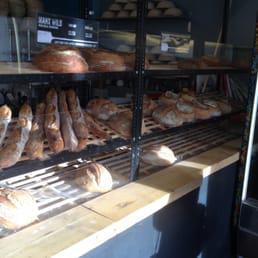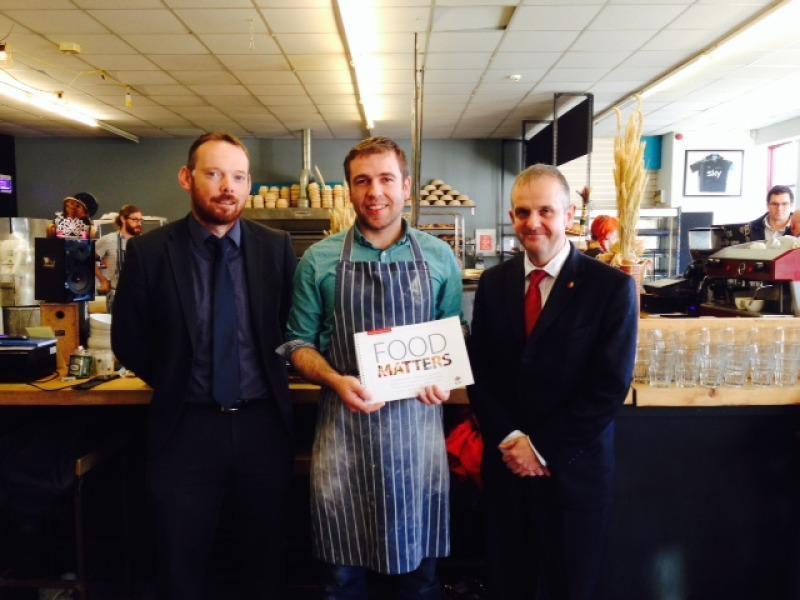The first image is the image on the left, the second image is the image on the right. Assess this claim about the two images: "there are wooden tables and chairs on a wooden floor". Correct or not? Answer yes or no. No. The first image is the image on the left, the second image is the image on the right. Analyze the images presented: Is the assertion "There is at least one chalkboard in the left image." valid? Answer yes or no. No. 